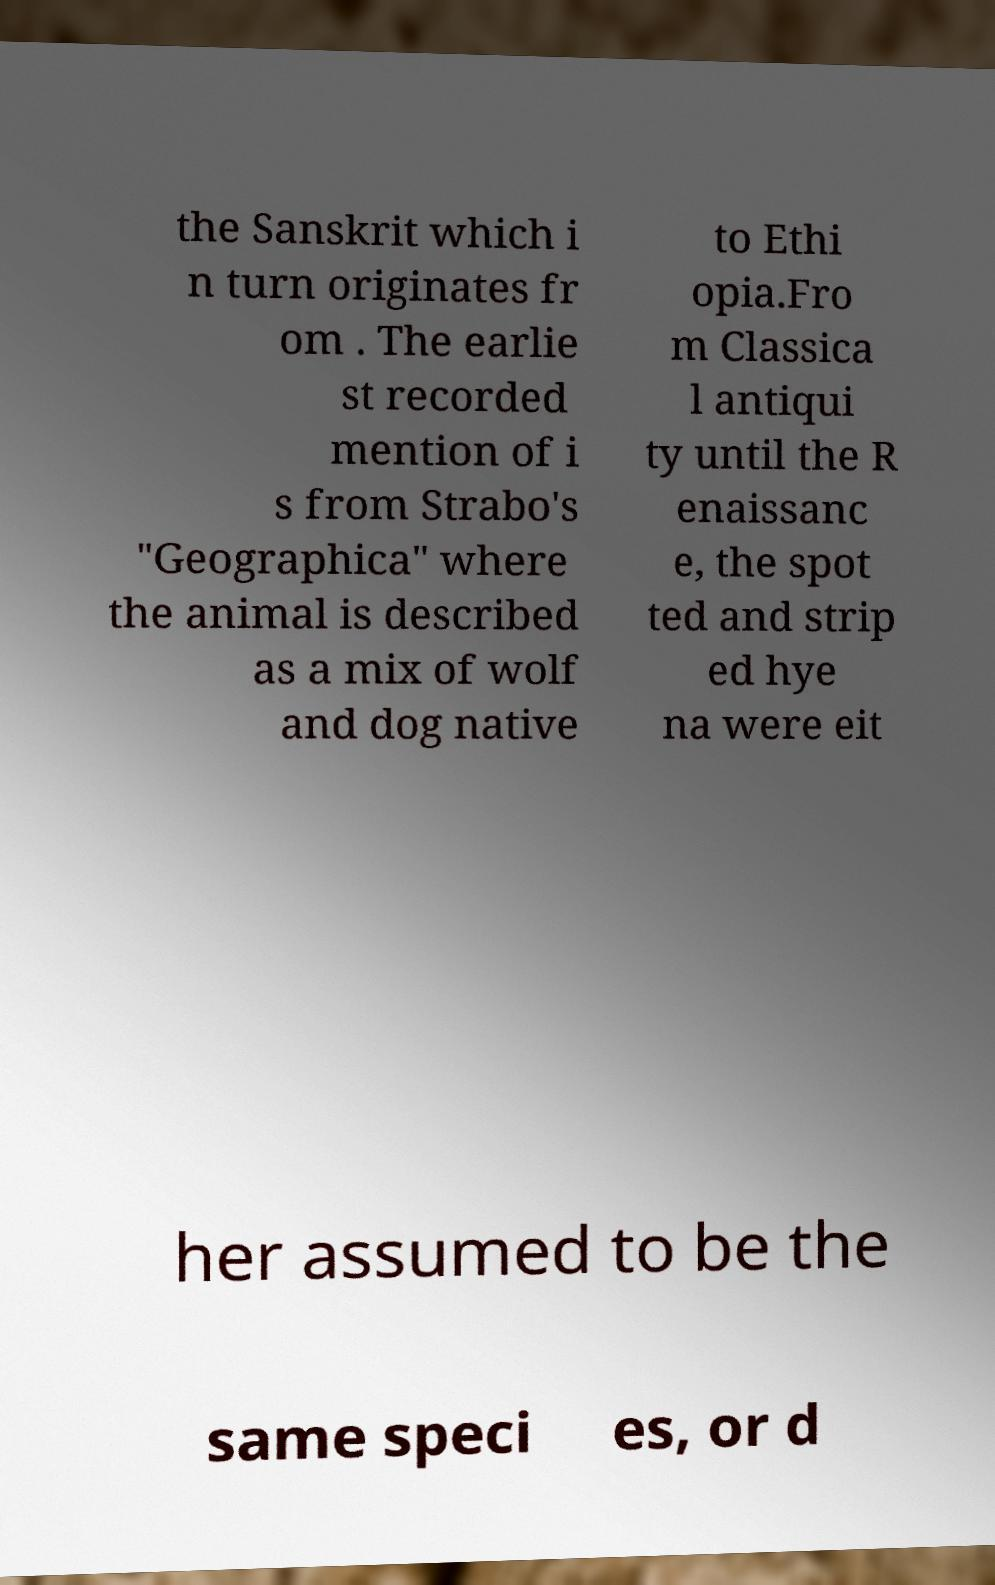Please identify and transcribe the text found in this image. the Sanskrit which i n turn originates fr om . The earlie st recorded mention of i s from Strabo's "Geographica" where the animal is described as a mix of wolf and dog native to Ethi opia.Fro m Classica l antiqui ty until the R enaissanc e, the spot ted and strip ed hye na were eit her assumed to be the same speci es, or d 